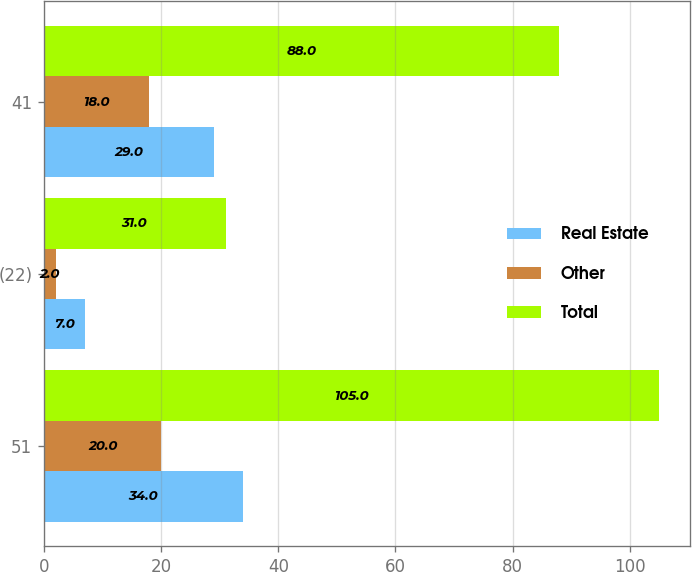Convert chart to OTSL. <chart><loc_0><loc_0><loc_500><loc_500><stacked_bar_chart><ecel><fcel>51<fcel>(22)<fcel>41<nl><fcel>Real Estate<fcel>34<fcel>7<fcel>29<nl><fcel>Other<fcel>20<fcel>2<fcel>18<nl><fcel>Total<fcel>105<fcel>31<fcel>88<nl></chart> 